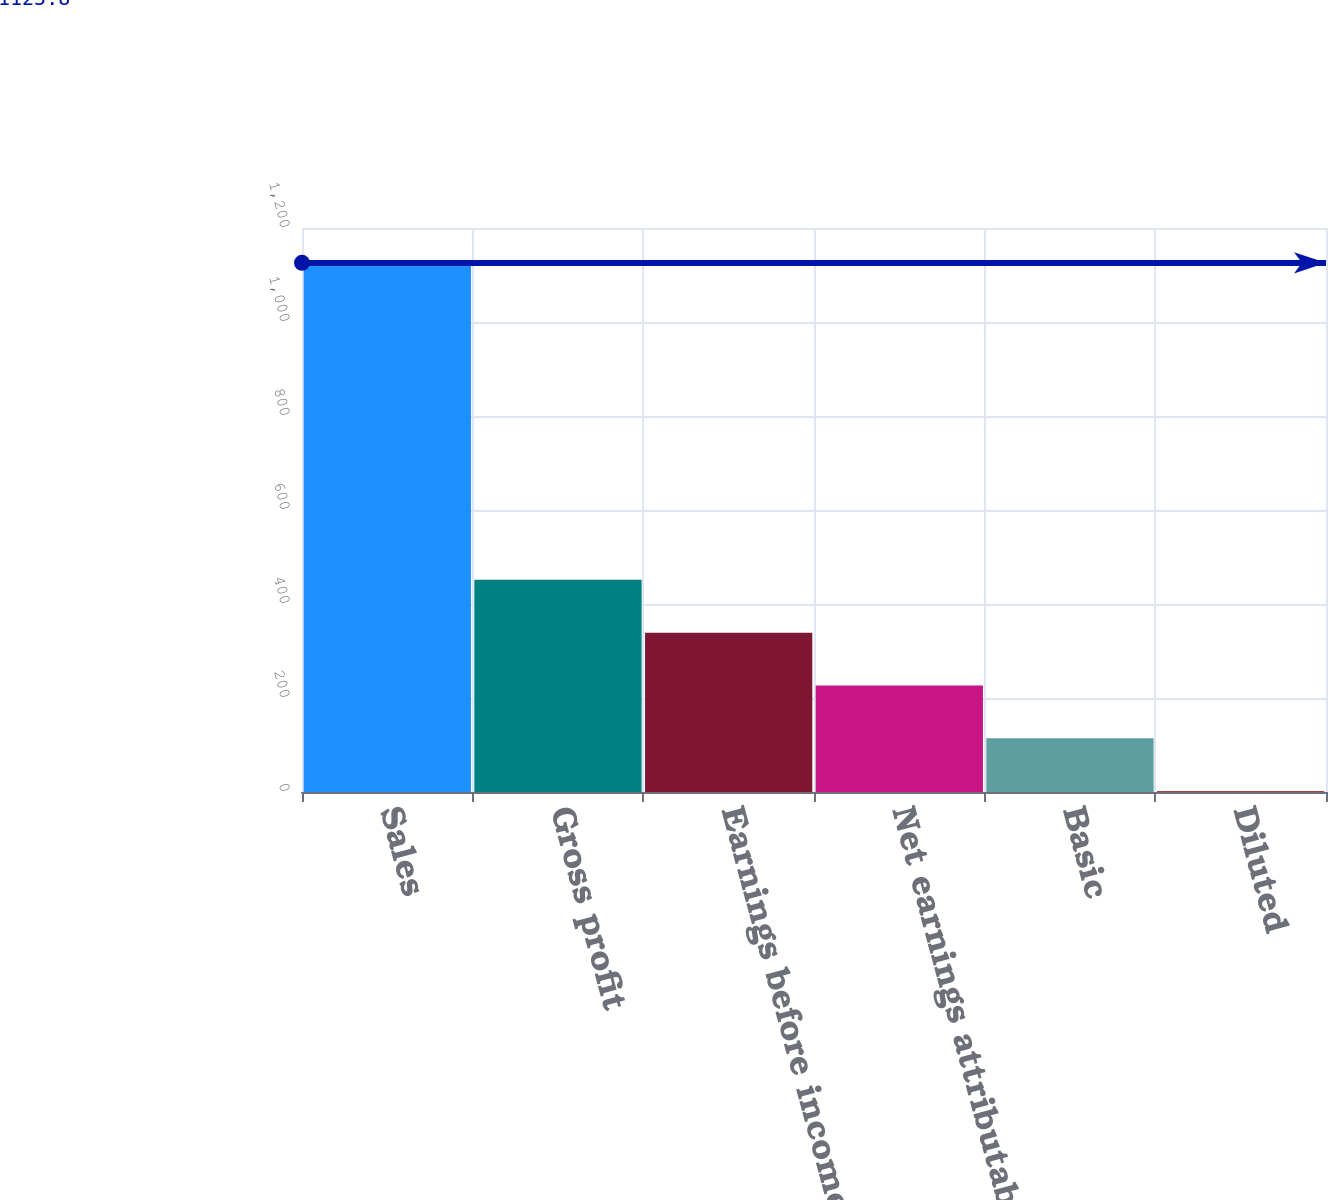<chart> <loc_0><loc_0><loc_500><loc_500><bar_chart><fcel>Sales<fcel>Gross profit<fcel>Earnings before income taxes<fcel>Net earnings attributable to<fcel>Basic<fcel>Diluted<nl><fcel>1125.8<fcel>451.36<fcel>338.96<fcel>226.56<fcel>114.16<fcel>1.76<nl></chart> 